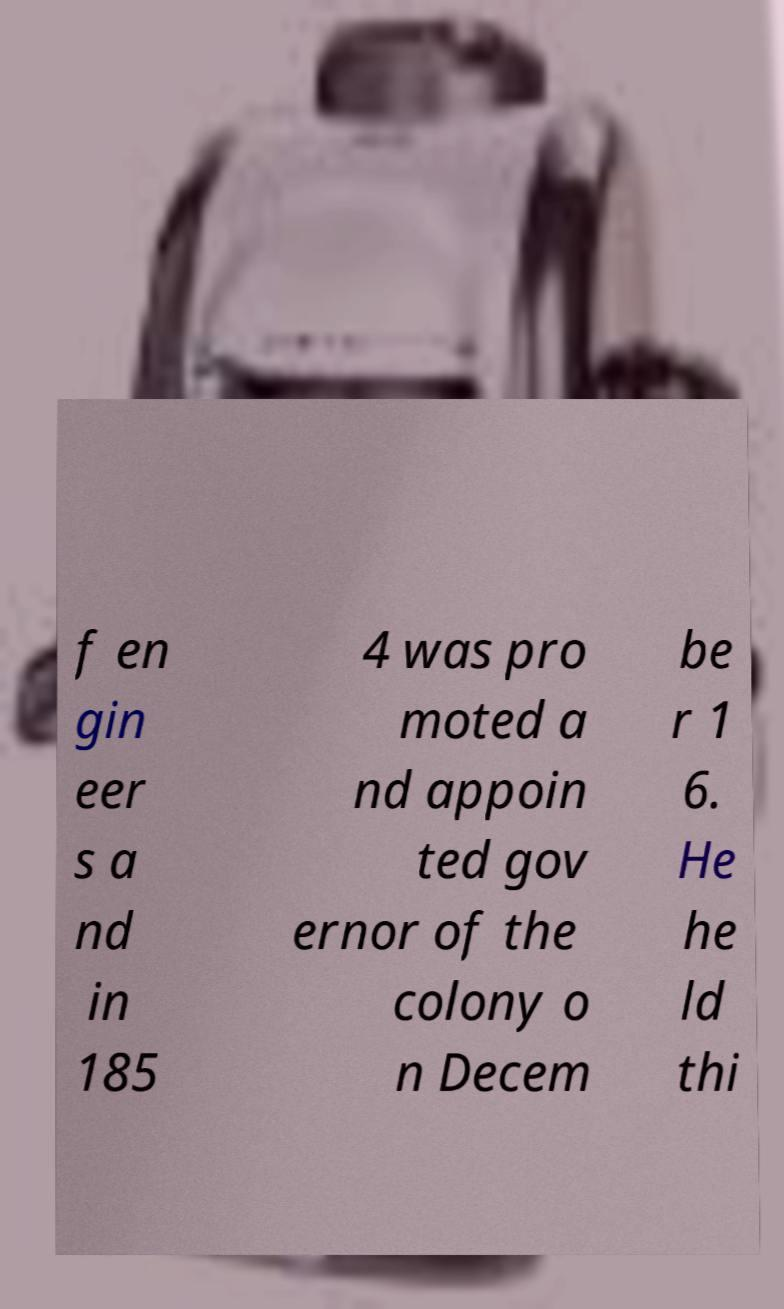Can you accurately transcribe the text from the provided image for me? f en gin eer s a nd in 185 4 was pro moted a nd appoin ted gov ernor of the colony o n Decem be r 1 6. He he ld thi 